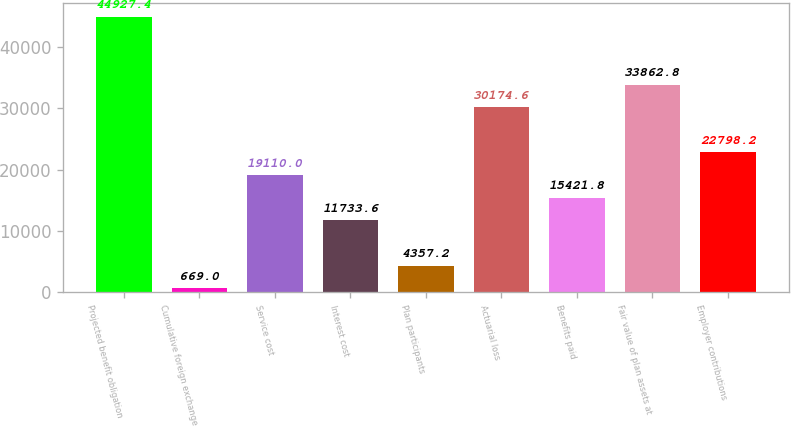Convert chart to OTSL. <chart><loc_0><loc_0><loc_500><loc_500><bar_chart><fcel>Projected benefit obligation<fcel>Cumulative foreign exchange<fcel>Service cost<fcel>Interest cost<fcel>Plan participants<fcel>Actuarial loss<fcel>Benefits paid<fcel>Fair value of plan assets at<fcel>Employer contributions<nl><fcel>44927.4<fcel>669<fcel>19110<fcel>11733.6<fcel>4357.2<fcel>30174.6<fcel>15421.8<fcel>33862.8<fcel>22798.2<nl></chart> 